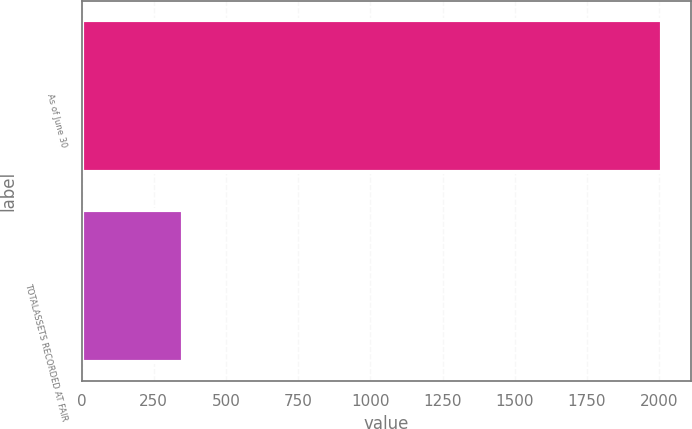Convert chart. <chart><loc_0><loc_0><loc_500><loc_500><bar_chart><fcel>As of June 30<fcel>TOTALASSETS RECORDED AT FAIR<nl><fcel>2011<fcel>350<nl></chart> 